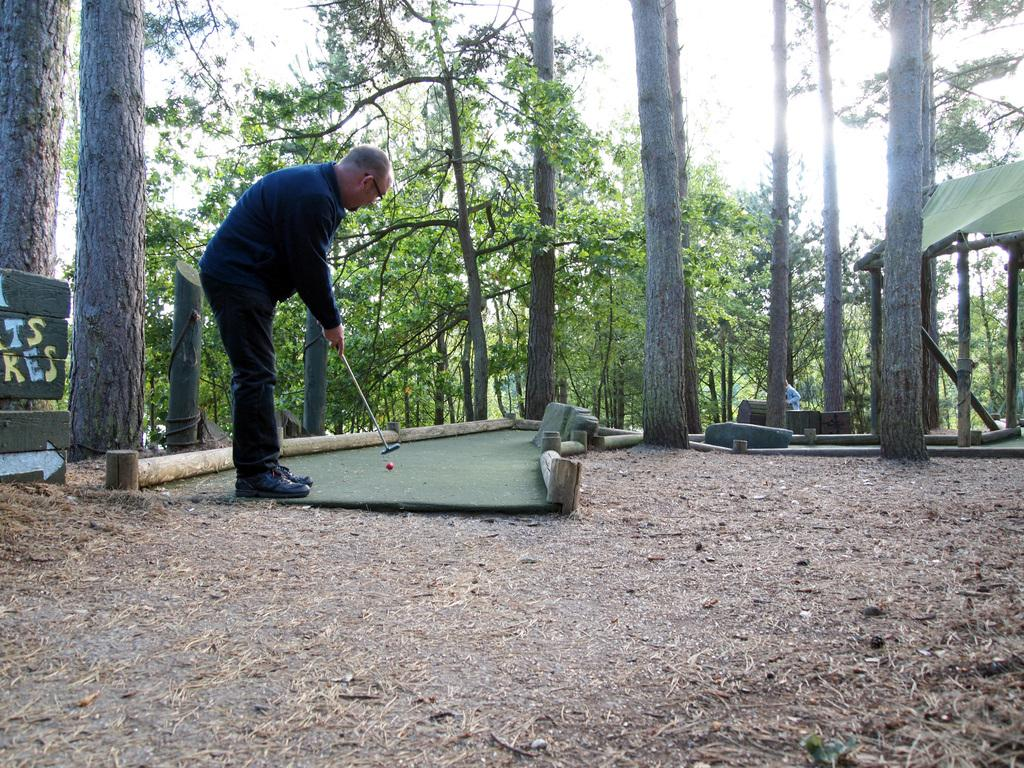What type of vegetation can be seen in the image? There are trees in the image. What is visible at the top of the image? The sky is visible at the top of the image. Can you describe the person in the image? There is a man standing in the front of the image, and he is wearing a black color jacket. What activity is the man engaged in? The man is playing golf. How many children are playing with the golf equipment in the image? There are no children present in the image, and no golf equipment is visible other than the man playing golf. What level of expertise does the man have in playing golf, as indicated by the image? The image does not provide any information about the man's level of expertise in playing golf. 